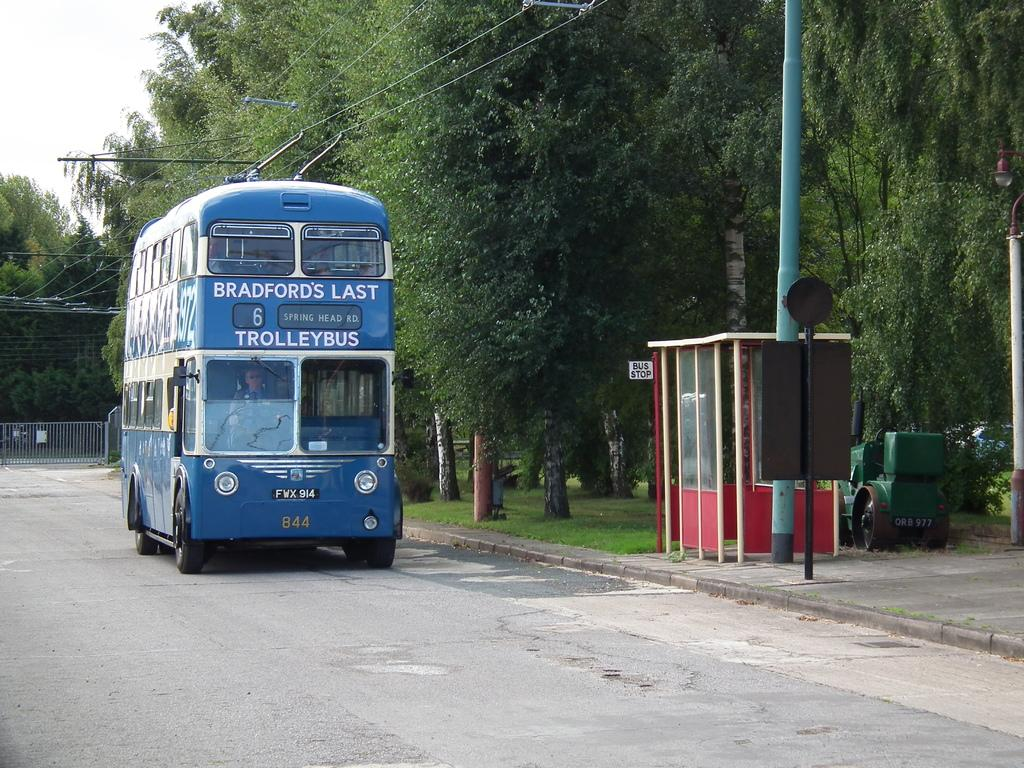<image>
Share a concise interpretation of the image provided. A blue double decker bus that says Bradford's Last Trolleybus. 